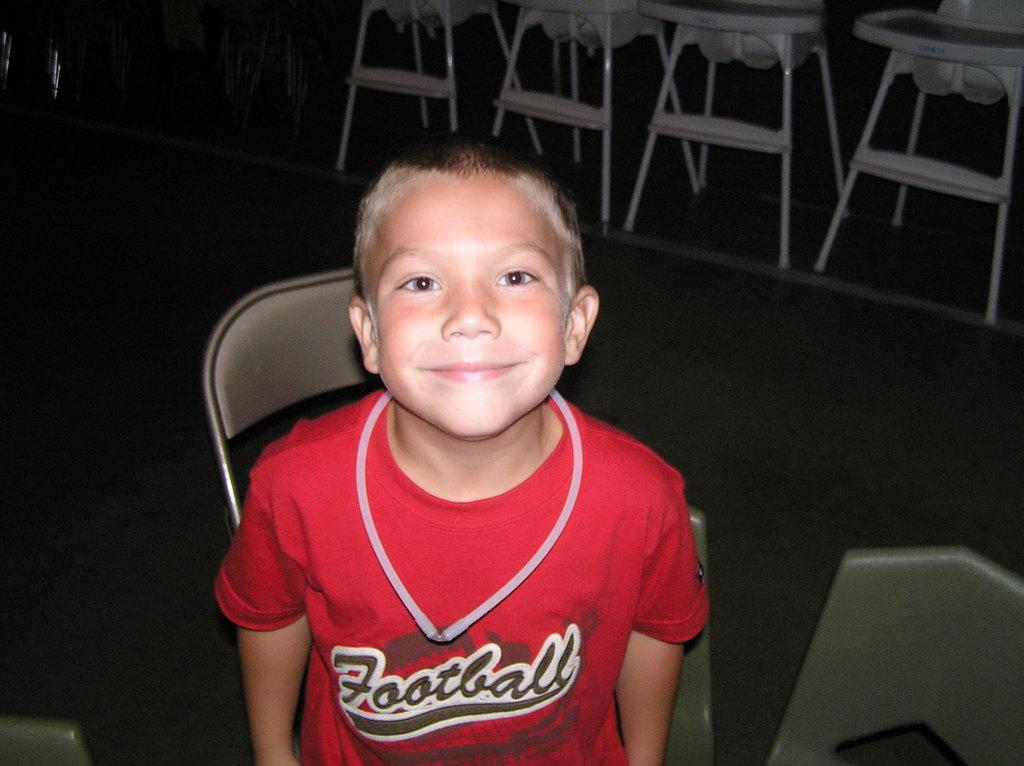What word is on the front of the shirt?
Offer a very short reply. Football. 